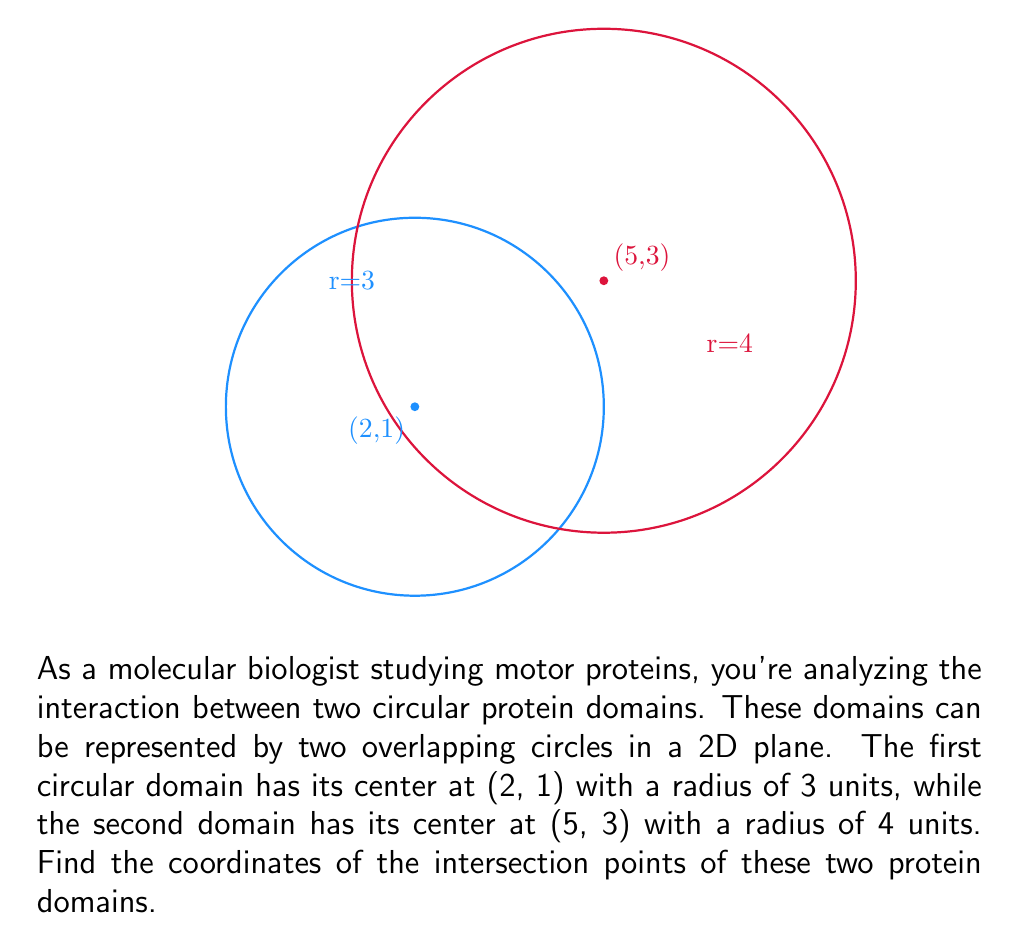Solve this math problem. Let's solve this step-by-step:

1) The equation of the first circle (centered at (2,1) with radius 3) is:
   $$(x-2)^2 + (y-1)^2 = 3^2$$

2) The equation of the second circle (centered at (5,3) with radius 4) is:
   $$(x-5)^2 + (y-3)^2 = 4^2$$

3) To find the intersection points, we need to solve these equations simultaneously.

4) Expand the equations:
   $x^2 - 4x + 4 + y^2 - 2y + 1 = 9$
   $x^2 - 10x + 25 + y^2 - 6y + 9 = 16$

5) Subtract the first equation from the second:
   $-6x + 21 - 4y + 8 = 7$
   $-6x - 4y = -22$

6) Solve this for y:
   $y = \frac{22 - 6x}{4} = \frac{11 - 3x}{2}$

7) Substitute this back into the equation of the first circle:
   $(x-2)^2 + (\frac{11 - 3x}{2} - 1)^2 = 9$

8) Simplify and solve for x:
   $(x-2)^2 + (\frac{9 - 3x}{2})^2 = 9$
   $x^2 - 4x + 4 + \frac{81 - 54x + 9x^2}{4} = 9$
   $4x^2 - 16x + 16 + 81 - 54x + 9x^2 = 36$
   $13x^2 - 70x + 61 = 0$

9) This is a quadratic equation. Solve it using the quadratic formula:
   $x = \frac{70 \pm \sqrt{70^2 - 4(13)(61)}}{2(13)}$
   $x \approx 4.38$ or $x \approx 1.00$

10) Substitute these x-values back into the equation for y:
    For $x \approx 4.38$: $y \approx 1.43$
    For $x \approx 1.00$: $y \approx 4.00$

Therefore, the intersection points are approximately (4.38, 1.43) and (1.00, 4.00).
Answer: (4.38, 1.43) and (1.00, 4.00) 